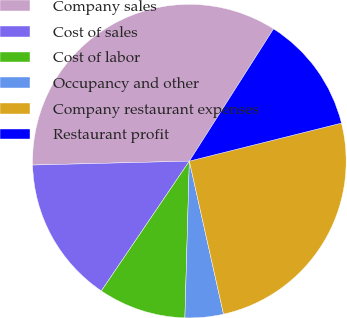Convert chart to OTSL. <chart><loc_0><loc_0><loc_500><loc_500><pie_chart><fcel>Company sales<fcel>Cost of sales<fcel>Cost of labor<fcel>Occupancy and other<fcel>Company restaurant expenses<fcel>Restaurant profit<nl><fcel>34.42%<fcel>15.12%<fcel>9.03%<fcel>3.95%<fcel>25.4%<fcel>12.08%<nl></chart> 